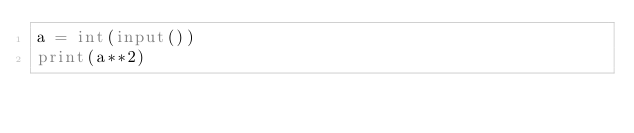<code> <loc_0><loc_0><loc_500><loc_500><_Python_>a = int(input())
print(a**2)
</code> 